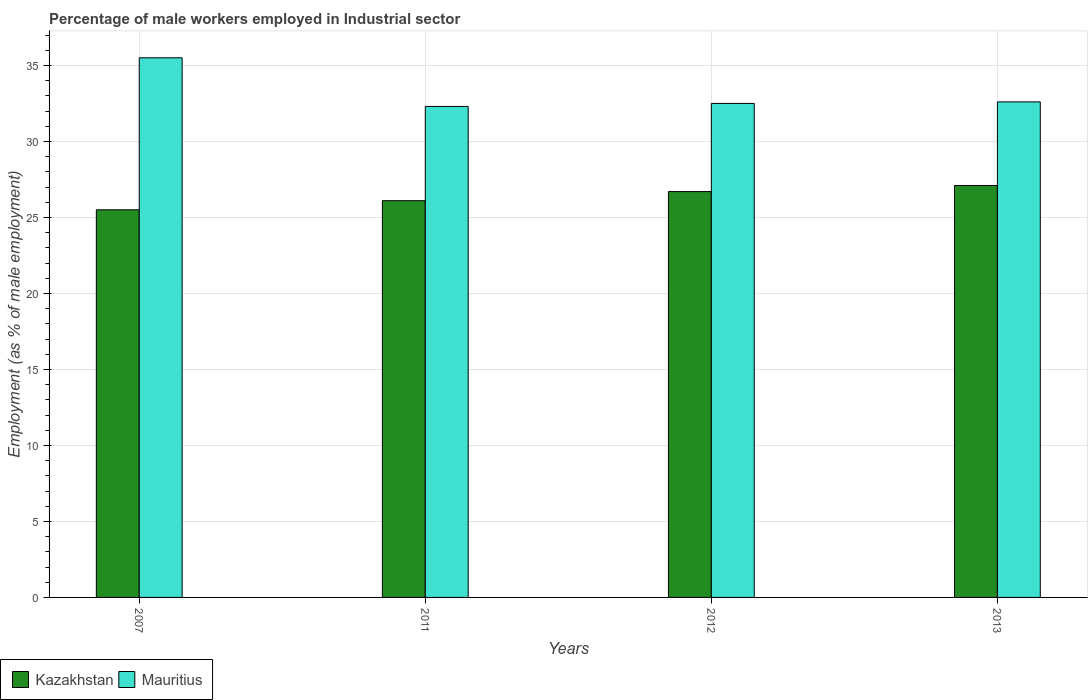How many groups of bars are there?
Offer a very short reply. 4. How many bars are there on the 4th tick from the right?
Provide a succinct answer. 2. What is the label of the 4th group of bars from the left?
Keep it short and to the point. 2013. What is the percentage of male workers employed in Industrial sector in Kazakhstan in 2011?
Provide a short and direct response. 26.1. Across all years, what is the maximum percentage of male workers employed in Industrial sector in Mauritius?
Offer a very short reply. 35.5. Across all years, what is the minimum percentage of male workers employed in Industrial sector in Kazakhstan?
Make the answer very short. 25.5. In which year was the percentage of male workers employed in Industrial sector in Kazakhstan maximum?
Offer a very short reply. 2013. What is the total percentage of male workers employed in Industrial sector in Kazakhstan in the graph?
Keep it short and to the point. 105.4. What is the difference between the percentage of male workers employed in Industrial sector in Mauritius in 2007 and the percentage of male workers employed in Industrial sector in Kazakhstan in 2012?
Your answer should be very brief. 8.8. What is the average percentage of male workers employed in Industrial sector in Mauritius per year?
Offer a terse response. 33.22. In the year 2012, what is the difference between the percentage of male workers employed in Industrial sector in Mauritius and percentage of male workers employed in Industrial sector in Kazakhstan?
Your answer should be compact. 5.8. What is the ratio of the percentage of male workers employed in Industrial sector in Kazakhstan in 2012 to that in 2013?
Give a very brief answer. 0.99. Is the percentage of male workers employed in Industrial sector in Kazakhstan in 2007 less than that in 2013?
Keep it short and to the point. Yes. Is the difference between the percentage of male workers employed in Industrial sector in Mauritius in 2007 and 2012 greater than the difference between the percentage of male workers employed in Industrial sector in Kazakhstan in 2007 and 2012?
Provide a succinct answer. Yes. What is the difference between the highest and the second highest percentage of male workers employed in Industrial sector in Mauritius?
Provide a succinct answer. 2.9. What is the difference between the highest and the lowest percentage of male workers employed in Industrial sector in Kazakhstan?
Offer a very short reply. 1.6. Is the sum of the percentage of male workers employed in Industrial sector in Mauritius in 2007 and 2011 greater than the maximum percentage of male workers employed in Industrial sector in Kazakhstan across all years?
Keep it short and to the point. Yes. What does the 1st bar from the left in 2012 represents?
Your answer should be very brief. Kazakhstan. What does the 2nd bar from the right in 2011 represents?
Give a very brief answer. Kazakhstan. How many bars are there?
Provide a succinct answer. 8. Does the graph contain grids?
Your response must be concise. Yes. Where does the legend appear in the graph?
Offer a very short reply. Bottom left. How many legend labels are there?
Your answer should be compact. 2. What is the title of the graph?
Offer a terse response. Percentage of male workers employed in Industrial sector. Does "Argentina" appear as one of the legend labels in the graph?
Ensure brevity in your answer.  No. What is the label or title of the X-axis?
Offer a terse response. Years. What is the label or title of the Y-axis?
Offer a terse response. Employment (as % of male employment). What is the Employment (as % of male employment) in Kazakhstan in 2007?
Offer a very short reply. 25.5. What is the Employment (as % of male employment) in Mauritius in 2007?
Make the answer very short. 35.5. What is the Employment (as % of male employment) of Kazakhstan in 2011?
Your answer should be compact. 26.1. What is the Employment (as % of male employment) of Mauritius in 2011?
Provide a succinct answer. 32.3. What is the Employment (as % of male employment) in Kazakhstan in 2012?
Your answer should be compact. 26.7. What is the Employment (as % of male employment) of Mauritius in 2012?
Give a very brief answer. 32.5. What is the Employment (as % of male employment) in Kazakhstan in 2013?
Give a very brief answer. 27.1. What is the Employment (as % of male employment) of Mauritius in 2013?
Ensure brevity in your answer.  32.6. Across all years, what is the maximum Employment (as % of male employment) in Kazakhstan?
Your answer should be very brief. 27.1. Across all years, what is the maximum Employment (as % of male employment) of Mauritius?
Your answer should be compact. 35.5. Across all years, what is the minimum Employment (as % of male employment) of Kazakhstan?
Your answer should be very brief. 25.5. Across all years, what is the minimum Employment (as % of male employment) of Mauritius?
Keep it short and to the point. 32.3. What is the total Employment (as % of male employment) of Kazakhstan in the graph?
Provide a succinct answer. 105.4. What is the total Employment (as % of male employment) of Mauritius in the graph?
Your response must be concise. 132.9. What is the difference between the Employment (as % of male employment) in Mauritius in 2007 and that in 2012?
Your answer should be very brief. 3. What is the difference between the Employment (as % of male employment) of Kazakhstan in 2007 and that in 2013?
Make the answer very short. -1.6. What is the difference between the Employment (as % of male employment) in Kazakhstan in 2011 and that in 2012?
Provide a short and direct response. -0.6. What is the difference between the Employment (as % of male employment) of Kazakhstan in 2011 and that in 2013?
Ensure brevity in your answer.  -1. What is the difference between the Employment (as % of male employment) of Mauritius in 2011 and that in 2013?
Provide a short and direct response. -0.3. What is the difference between the Employment (as % of male employment) in Mauritius in 2012 and that in 2013?
Make the answer very short. -0.1. What is the difference between the Employment (as % of male employment) of Kazakhstan in 2007 and the Employment (as % of male employment) of Mauritius in 2013?
Provide a short and direct response. -7.1. What is the difference between the Employment (as % of male employment) in Kazakhstan in 2012 and the Employment (as % of male employment) in Mauritius in 2013?
Your answer should be very brief. -5.9. What is the average Employment (as % of male employment) of Kazakhstan per year?
Your answer should be compact. 26.35. What is the average Employment (as % of male employment) in Mauritius per year?
Provide a succinct answer. 33.23. In the year 2007, what is the difference between the Employment (as % of male employment) in Kazakhstan and Employment (as % of male employment) in Mauritius?
Give a very brief answer. -10. In the year 2012, what is the difference between the Employment (as % of male employment) of Kazakhstan and Employment (as % of male employment) of Mauritius?
Provide a short and direct response. -5.8. What is the ratio of the Employment (as % of male employment) in Kazakhstan in 2007 to that in 2011?
Give a very brief answer. 0.98. What is the ratio of the Employment (as % of male employment) of Mauritius in 2007 to that in 2011?
Provide a succinct answer. 1.1. What is the ratio of the Employment (as % of male employment) in Kazakhstan in 2007 to that in 2012?
Make the answer very short. 0.96. What is the ratio of the Employment (as % of male employment) of Mauritius in 2007 to that in 2012?
Provide a succinct answer. 1.09. What is the ratio of the Employment (as % of male employment) of Kazakhstan in 2007 to that in 2013?
Offer a very short reply. 0.94. What is the ratio of the Employment (as % of male employment) of Mauritius in 2007 to that in 2013?
Make the answer very short. 1.09. What is the ratio of the Employment (as % of male employment) in Kazakhstan in 2011 to that in 2012?
Your answer should be compact. 0.98. What is the ratio of the Employment (as % of male employment) of Mauritius in 2011 to that in 2012?
Offer a terse response. 0.99. What is the ratio of the Employment (as % of male employment) of Kazakhstan in 2011 to that in 2013?
Offer a very short reply. 0.96. What is the ratio of the Employment (as % of male employment) in Kazakhstan in 2012 to that in 2013?
Offer a terse response. 0.99. What is the ratio of the Employment (as % of male employment) of Mauritius in 2012 to that in 2013?
Make the answer very short. 1. What is the difference between the highest and the second highest Employment (as % of male employment) of Mauritius?
Provide a short and direct response. 2.9. What is the difference between the highest and the lowest Employment (as % of male employment) of Kazakhstan?
Your answer should be compact. 1.6. 